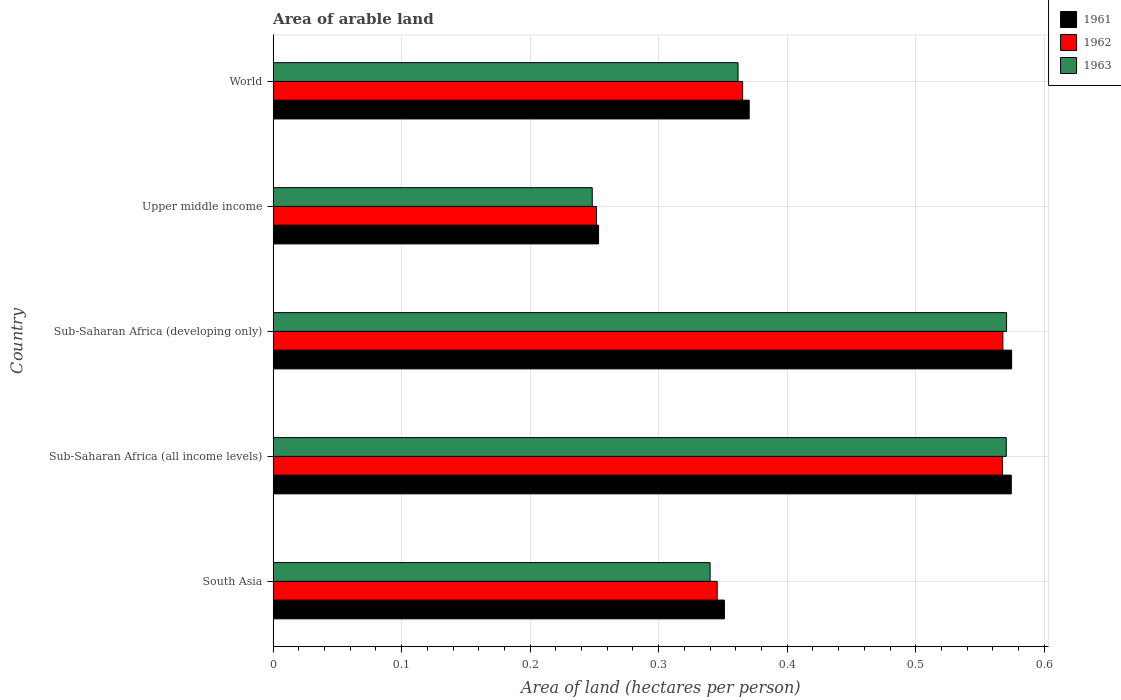How many groups of bars are there?
Provide a short and direct response. 5. Are the number of bars per tick equal to the number of legend labels?
Provide a succinct answer. Yes. How many bars are there on the 5th tick from the top?
Provide a short and direct response. 3. How many bars are there on the 2nd tick from the bottom?
Make the answer very short. 3. What is the total arable land in 1962 in Sub-Saharan Africa (developing only)?
Give a very brief answer. 0.57. Across all countries, what is the maximum total arable land in 1963?
Keep it short and to the point. 0.57. Across all countries, what is the minimum total arable land in 1962?
Your answer should be compact. 0.25. In which country was the total arable land in 1961 maximum?
Keep it short and to the point. Sub-Saharan Africa (developing only). In which country was the total arable land in 1961 minimum?
Offer a very short reply. Upper middle income. What is the total total arable land in 1962 in the graph?
Your answer should be very brief. 2.1. What is the difference between the total arable land in 1963 in Sub-Saharan Africa (all income levels) and that in World?
Keep it short and to the point. 0.21. What is the difference between the total arable land in 1962 in Sub-Saharan Africa (developing only) and the total arable land in 1963 in Sub-Saharan Africa (all income levels)?
Give a very brief answer. -0. What is the average total arable land in 1961 per country?
Keep it short and to the point. 0.42. What is the difference between the total arable land in 1961 and total arable land in 1963 in Sub-Saharan Africa (all income levels)?
Offer a very short reply. 0. In how many countries, is the total arable land in 1963 greater than 0.2 hectares per person?
Offer a very short reply. 5. What is the ratio of the total arable land in 1963 in Sub-Saharan Africa (all income levels) to that in Upper middle income?
Keep it short and to the point. 2.3. Is the total arable land in 1962 in Sub-Saharan Africa (all income levels) less than that in Sub-Saharan Africa (developing only)?
Offer a very short reply. Yes. Is the difference between the total arable land in 1961 in South Asia and Sub-Saharan Africa (all income levels) greater than the difference between the total arable land in 1963 in South Asia and Sub-Saharan Africa (all income levels)?
Your answer should be very brief. Yes. What is the difference between the highest and the second highest total arable land in 1963?
Give a very brief answer. 0. What is the difference between the highest and the lowest total arable land in 1961?
Offer a very short reply. 0.32. Is the sum of the total arable land in 1961 in Upper middle income and World greater than the maximum total arable land in 1963 across all countries?
Your answer should be very brief. Yes. What does the 2nd bar from the bottom in Upper middle income represents?
Offer a very short reply. 1962. How many countries are there in the graph?
Make the answer very short. 5. What is the difference between two consecutive major ticks on the X-axis?
Your answer should be very brief. 0.1. Are the values on the major ticks of X-axis written in scientific E-notation?
Keep it short and to the point. No. How many legend labels are there?
Your answer should be compact. 3. How are the legend labels stacked?
Give a very brief answer. Vertical. What is the title of the graph?
Make the answer very short. Area of arable land. What is the label or title of the X-axis?
Offer a terse response. Area of land (hectares per person). What is the label or title of the Y-axis?
Provide a succinct answer. Country. What is the Area of land (hectares per person) of 1961 in South Asia?
Offer a very short reply. 0.35. What is the Area of land (hectares per person) in 1962 in South Asia?
Your answer should be compact. 0.35. What is the Area of land (hectares per person) in 1963 in South Asia?
Keep it short and to the point. 0.34. What is the Area of land (hectares per person) of 1961 in Sub-Saharan Africa (all income levels)?
Offer a very short reply. 0.57. What is the Area of land (hectares per person) of 1962 in Sub-Saharan Africa (all income levels)?
Your response must be concise. 0.57. What is the Area of land (hectares per person) of 1963 in Sub-Saharan Africa (all income levels)?
Make the answer very short. 0.57. What is the Area of land (hectares per person) in 1961 in Sub-Saharan Africa (developing only)?
Offer a terse response. 0.57. What is the Area of land (hectares per person) in 1962 in Sub-Saharan Africa (developing only)?
Keep it short and to the point. 0.57. What is the Area of land (hectares per person) of 1963 in Sub-Saharan Africa (developing only)?
Give a very brief answer. 0.57. What is the Area of land (hectares per person) in 1961 in Upper middle income?
Provide a short and direct response. 0.25. What is the Area of land (hectares per person) of 1962 in Upper middle income?
Your response must be concise. 0.25. What is the Area of land (hectares per person) in 1963 in Upper middle income?
Offer a terse response. 0.25. What is the Area of land (hectares per person) in 1961 in World?
Provide a succinct answer. 0.37. What is the Area of land (hectares per person) in 1962 in World?
Your answer should be compact. 0.37. What is the Area of land (hectares per person) in 1963 in World?
Give a very brief answer. 0.36. Across all countries, what is the maximum Area of land (hectares per person) in 1961?
Keep it short and to the point. 0.57. Across all countries, what is the maximum Area of land (hectares per person) in 1962?
Keep it short and to the point. 0.57. Across all countries, what is the maximum Area of land (hectares per person) in 1963?
Your answer should be compact. 0.57. Across all countries, what is the minimum Area of land (hectares per person) in 1961?
Provide a succinct answer. 0.25. Across all countries, what is the minimum Area of land (hectares per person) of 1962?
Your answer should be very brief. 0.25. Across all countries, what is the minimum Area of land (hectares per person) of 1963?
Your answer should be compact. 0.25. What is the total Area of land (hectares per person) of 1961 in the graph?
Keep it short and to the point. 2.12. What is the total Area of land (hectares per person) of 1962 in the graph?
Your answer should be compact. 2.1. What is the total Area of land (hectares per person) in 1963 in the graph?
Provide a succinct answer. 2.09. What is the difference between the Area of land (hectares per person) in 1961 in South Asia and that in Sub-Saharan Africa (all income levels)?
Provide a short and direct response. -0.22. What is the difference between the Area of land (hectares per person) in 1962 in South Asia and that in Sub-Saharan Africa (all income levels)?
Ensure brevity in your answer.  -0.22. What is the difference between the Area of land (hectares per person) of 1963 in South Asia and that in Sub-Saharan Africa (all income levels)?
Give a very brief answer. -0.23. What is the difference between the Area of land (hectares per person) of 1961 in South Asia and that in Sub-Saharan Africa (developing only)?
Your answer should be compact. -0.22. What is the difference between the Area of land (hectares per person) of 1962 in South Asia and that in Sub-Saharan Africa (developing only)?
Offer a terse response. -0.22. What is the difference between the Area of land (hectares per person) of 1963 in South Asia and that in Sub-Saharan Africa (developing only)?
Offer a very short reply. -0.23. What is the difference between the Area of land (hectares per person) of 1961 in South Asia and that in Upper middle income?
Provide a short and direct response. 0.1. What is the difference between the Area of land (hectares per person) of 1962 in South Asia and that in Upper middle income?
Your response must be concise. 0.09. What is the difference between the Area of land (hectares per person) of 1963 in South Asia and that in Upper middle income?
Your answer should be compact. 0.09. What is the difference between the Area of land (hectares per person) of 1961 in South Asia and that in World?
Provide a succinct answer. -0.02. What is the difference between the Area of land (hectares per person) in 1962 in South Asia and that in World?
Your answer should be compact. -0.02. What is the difference between the Area of land (hectares per person) of 1963 in South Asia and that in World?
Your answer should be very brief. -0.02. What is the difference between the Area of land (hectares per person) of 1961 in Sub-Saharan Africa (all income levels) and that in Sub-Saharan Africa (developing only)?
Offer a very short reply. -0. What is the difference between the Area of land (hectares per person) of 1962 in Sub-Saharan Africa (all income levels) and that in Sub-Saharan Africa (developing only)?
Offer a terse response. -0. What is the difference between the Area of land (hectares per person) in 1963 in Sub-Saharan Africa (all income levels) and that in Sub-Saharan Africa (developing only)?
Keep it short and to the point. -0. What is the difference between the Area of land (hectares per person) of 1961 in Sub-Saharan Africa (all income levels) and that in Upper middle income?
Provide a succinct answer. 0.32. What is the difference between the Area of land (hectares per person) in 1962 in Sub-Saharan Africa (all income levels) and that in Upper middle income?
Your response must be concise. 0.32. What is the difference between the Area of land (hectares per person) of 1963 in Sub-Saharan Africa (all income levels) and that in Upper middle income?
Provide a short and direct response. 0.32. What is the difference between the Area of land (hectares per person) of 1961 in Sub-Saharan Africa (all income levels) and that in World?
Keep it short and to the point. 0.2. What is the difference between the Area of land (hectares per person) of 1962 in Sub-Saharan Africa (all income levels) and that in World?
Your response must be concise. 0.2. What is the difference between the Area of land (hectares per person) of 1963 in Sub-Saharan Africa (all income levels) and that in World?
Provide a succinct answer. 0.21. What is the difference between the Area of land (hectares per person) of 1961 in Sub-Saharan Africa (developing only) and that in Upper middle income?
Provide a short and direct response. 0.32. What is the difference between the Area of land (hectares per person) in 1962 in Sub-Saharan Africa (developing only) and that in Upper middle income?
Provide a short and direct response. 0.32. What is the difference between the Area of land (hectares per person) of 1963 in Sub-Saharan Africa (developing only) and that in Upper middle income?
Your answer should be compact. 0.32. What is the difference between the Area of land (hectares per person) of 1961 in Sub-Saharan Africa (developing only) and that in World?
Make the answer very short. 0.2. What is the difference between the Area of land (hectares per person) of 1962 in Sub-Saharan Africa (developing only) and that in World?
Give a very brief answer. 0.2. What is the difference between the Area of land (hectares per person) in 1963 in Sub-Saharan Africa (developing only) and that in World?
Your answer should be compact. 0.21. What is the difference between the Area of land (hectares per person) of 1961 in Upper middle income and that in World?
Provide a succinct answer. -0.12. What is the difference between the Area of land (hectares per person) of 1962 in Upper middle income and that in World?
Keep it short and to the point. -0.11. What is the difference between the Area of land (hectares per person) of 1963 in Upper middle income and that in World?
Ensure brevity in your answer.  -0.11. What is the difference between the Area of land (hectares per person) in 1961 in South Asia and the Area of land (hectares per person) in 1962 in Sub-Saharan Africa (all income levels)?
Your response must be concise. -0.22. What is the difference between the Area of land (hectares per person) in 1961 in South Asia and the Area of land (hectares per person) in 1963 in Sub-Saharan Africa (all income levels)?
Offer a terse response. -0.22. What is the difference between the Area of land (hectares per person) in 1962 in South Asia and the Area of land (hectares per person) in 1963 in Sub-Saharan Africa (all income levels)?
Keep it short and to the point. -0.23. What is the difference between the Area of land (hectares per person) of 1961 in South Asia and the Area of land (hectares per person) of 1962 in Sub-Saharan Africa (developing only)?
Provide a succinct answer. -0.22. What is the difference between the Area of land (hectares per person) in 1961 in South Asia and the Area of land (hectares per person) in 1963 in Sub-Saharan Africa (developing only)?
Keep it short and to the point. -0.22. What is the difference between the Area of land (hectares per person) in 1962 in South Asia and the Area of land (hectares per person) in 1963 in Sub-Saharan Africa (developing only)?
Your answer should be very brief. -0.23. What is the difference between the Area of land (hectares per person) in 1961 in South Asia and the Area of land (hectares per person) in 1962 in Upper middle income?
Give a very brief answer. 0.1. What is the difference between the Area of land (hectares per person) of 1961 in South Asia and the Area of land (hectares per person) of 1963 in Upper middle income?
Provide a short and direct response. 0.1. What is the difference between the Area of land (hectares per person) of 1962 in South Asia and the Area of land (hectares per person) of 1963 in Upper middle income?
Ensure brevity in your answer.  0.1. What is the difference between the Area of land (hectares per person) of 1961 in South Asia and the Area of land (hectares per person) of 1962 in World?
Provide a succinct answer. -0.01. What is the difference between the Area of land (hectares per person) of 1961 in South Asia and the Area of land (hectares per person) of 1963 in World?
Provide a short and direct response. -0.01. What is the difference between the Area of land (hectares per person) in 1962 in South Asia and the Area of land (hectares per person) in 1963 in World?
Your answer should be compact. -0.02. What is the difference between the Area of land (hectares per person) in 1961 in Sub-Saharan Africa (all income levels) and the Area of land (hectares per person) in 1962 in Sub-Saharan Africa (developing only)?
Provide a succinct answer. 0.01. What is the difference between the Area of land (hectares per person) of 1961 in Sub-Saharan Africa (all income levels) and the Area of land (hectares per person) of 1963 in Sub-Saharan Africa (developing only)?
Keep it short and to the point. 0. What is the difference between the Area of land (hectares per person) in 1962 in Sub-Saharan Africa (all income levels) and the Area of land (hectares per person) in 1963 in Sub-Saharan Africa (developing only)?
Make the answer very short. -0. What is the difference between the Area of land (hectares per person) in 1961 in Sub-Saharan Africa (all income levels) and the Area of land (hectares per person) in 1962 in Upper middle income?
Your response must be concise. 0.32. What is the difference between the Area of land (hectares per person) of 1961 in Sub-Saharan Africa (all income levels) and the Area of land (hectares per person) of 1963 in Upper middle income?
Offer a terse response. 0.33. What is the difference between the Area of land (hectares per person) of 1962 in Sub-Saharan Africa (all income levels) and the Area of land (hectares per person) of 1963 in Upper middle income?
Provide a short and direct response. 0.32. What is the difference between the Area of land (hectares per person) of 1961 in Sub-Saharan Africa (all income levels) and the Area of land (hectares per person) of 1962 in World?
Offer a terse response. 0.21. What is the difference between the Area of land (hectares per person) in 1961 in Sub-Saharan Africa (all income levels) and the Area of land (hectares per person) in 1963 in World?
Offer a terse response. 0.21. What is the difference between the Area of land (hectares per person) in 1962 in Sub-Saharan Africa (all income levels) and the Area of land (hectares per person) in 1963 in World?
Your response must be concise. 0.21. What is the difference between the Area of land (hectares per person) of 1961 in Sub-Saharan Africa (developing only) and the Area of land (hectares per person) of 1962 in Upper middle income?
Your answer should be very brief. 0.32. What is the difference between the Area of land (hectares per person) in 1961 in Sub-Saharan Africa (developing only) and the Area of land (hectares per person) in 1963 in Upper middle income?
Your answer should be very brief. 0.33. What is the difference between the Area of land (hectares per person) in 1962 in Sub-Saharan Africa (developing only) and the Area of land (hectares per person) in 1963 in Upper middle income?
Provide a short and direct response. 0.32. What is the difference between the Area of land (hectares per person) in 1961 in Sub-Saharan Africa (developing only) and the Area of land (hectares per person) in 1962 in World?
Your answer should be very brief. 0.21. What is the difference between the Area of land (hectares per person) in 1961 in Sub-Saharan Africa (developing only) and the Area of land (hectares per person) in 1963 in World?
Provide a succinct answer. 0.21. What is the difference between the Area of land (hectares per person) in 1962 in Sub-Saharan Africa (developing only) and the Area of land (hectares per person) in 1963 in World?
Keep it short and to the point. 0.21. What is the difference between the Area of land (hectares per person) in 1961 in Upper middle income and the Area of land (hectares per person) in 1962 in World?
Offer a terse response. -0.11. What is the difference between the Area of land (hectares per person) of 1961 in Upper middle income and the Area of land (hectares per person) of 1963 in World?
Provide a short and direct response. -0.11. What is the difference between the Area of land (hectares per person) of 1962 in Upper middle income and the Area of land (hectares per person) of 1963 in World?
Provide a succinct answer. -0.11. What is the average Area of land (hectares per person) in 1961 per country?
Offer a very short reply. 0.42. What is the average Area of land (hectares per person) in 1962 per country?
Offer a very short reply. 0.42. What is the average Area of land (hectares per person) of 1963 per country?
Your answer should be compact. 0.42. What is the difference between the Area of land (hectares per person) of 1961 and Area of land (hectares per person) of 1962 in South Asia?
Offer a terse response. 0.01. What is the difference between the Area of land (hectares per person) in 1961 and Area of land (hectares per person) in 1963 in South Asia?
Your response must be concise. 0.01. What is the difference between the Area of land (hectares per person) of 1962 and Area of land (hectares per person) of 1963 in South Asia?
Your answer should be very brief. 0.01. What is the difference between the Area of land (hectares per person) of 1961 and Area of land (hectares per person) of 1962 in Sub-Saharan Africa (all income levels)?
Provide a short and direct response. 0.01. What is the difference between the Area of land (hectares per person) in 1961 and Area of land (hectares per person) in 1963 in Sub-Saharan Africa (all income levels)?
Ensure brevity in your answer.  0. What is the difference between the Area of land (hectares per person) in 1962 and Area of land (hectares per person) in 1963 in Sub-Saharan Africa (all income levels)?
Ensure brevity in your answer.  -0. What is the difference between the Area of land (hectares per person) of 1961 and Area of land (hectares per person) of 1962 in Sub-Saharan Africa (developing only)?
Provide a short and direct response. 0.01. What is the difference between the Area of land (hectares per person) of 1961 and Area of land (hectares per person) of 1963 in Sub-Saharan Africa (developing only)?
Offer a very short reply. 0. What is the difference between the Area of land (hectares per person) in 1962 and Area of land (hectares per person) in 1963 in Sub-Saharan Africa (developing only)?
Your response must be concise. -0. What is the difference between the Area of land (hectares per person) of 1961 and Area of land (hectares per person) of 1962 in Upper middle income?
Ensure brevity in your answer.  0. What is the difference between the Area of land (hectares per person) in 1961 and Area of land (hectares per person) in 1963 in Upper middle income?
Offer a terse response. 0. What is the difference between the Area of land (hectares per person) of 1962 and Area of land (hectares per person) of 1963 in Upper middle income?
Provide a succinct answer. 0. What is the difference between the Area of land (hectares per person) in 1961 and Area of land (hectares per person) in 1962 in World?
Your response must be concise. 0.01. What is the difference between the Area of land (hectares per person) in 1961 and Area of land (hectares per person) in 1963 in World?
Provide a succinct answer. 0.01. What is the difference between the Area of land (hectares per person) of 1962 and Area of land (hectares per person) of 1963 in World?
Your answer should be compact. 0. What is the ratio of the Area of land (hectares per person) in 1961 in South Asia to that in Sub-Saharan Africa (all income levels)?
Offer a terse response. 0.61. What is the ratio of the Area of land (hectares per person) in 1962 in South Asia to that in Sub-Saharan Africa (all income levels)?
Make the answer very short. 0.61. What is the ratio of the Area of land (hectares per person) of 1963 in South Asia to that in Sub-Saharan Africa (all income levels)?
Your answer should be very brief. 0.6. What is the ratio of the Area of land (hectares per person) of 1961 in South Asia to that in Sub-Saharan Africa (developing only)?
Keep it short and to the point. 0.61. What is the ratio of the Area of land (hectares per person) of 1962 in South Asia to that in Sub-Saharan Africa (developing only)?
Give a very brief answer. 0.61. What is the ratio of the Area of land (hectares per person) in 1963 in South Asia to that in Sub-Saharan Africa (developing only)?
Offer a very short reply. 0.6. What is the ratio of the Area of land (hectares per person) of 1961 in South Asia to that in Upper middle income?
Ensure brevity in your answer.  1.39. What is the ratio of the Area of land (hectares per person) in 1962 in South Asia to that in Upper middle income?
Your response must be concise. 1.37. What is the ratio of the Area of land (hectares per person) in 1963 in South Asia to that in Upper middle income?
Your response must be concise. 1.37. What is the ratio of the Area of land (hectares per person) of 1961 in South Asia to that in World?
Ensure brevity in your answer.  0.95. What is the ratio of the Area of land (hectares per person) of 1962 in South Asia to that in World?
Your answer should be very brief. 0.95. What is the ratio of the Area of land (hectares per person) in 1963 in South Asia to that in World?
Provide a short and direct response. 0.94. What is the ratio of the Area of land (hectares per person) of 1962 in Sub-Saharan Africa (all income levels) to that in Sub-Saharan Africa (developing only)?
Give a very brief answer. 1. What is the ratio of the Area of land (hectares per person) of 1961 in Sub-Saharan Africa (all income levels) to that in Upper middle income?
Your answer should be compact. 2.27. What is the ratio of the Area of land (hectares per person) in 1962 in Sub-Saharan Africa (all income levels) to that in Upper middle income?
Your answer should be compact. 2.26. What is the ratio of the Area of land (hectares per person) in 1963 in Sub-Saharan Africa (all income levels) to that in Upper middle income?
Offer a very short reply. 2.3. What is the ratio of the Area of land (hectares per person) of 1961 in Sub-Saharan Africa (all income levels) to that in World?
Provide a short and direct response. 1.55. What is the ratio of the Area of land (hectares per person) of 1962 in Sub-Saharan Africa (all income levels) to that in World?
Offer a terse response. 1.55. What is the ratio of the Area of land (hectares per person) in 1963 in Sub-Saharan Africa (all income levels) to that in World?
Your answer should be very brief. 1.58. What is the ratio of the Area of land (hectares per person) of 1961 in Sub-Saharan Africa (developing only) to that in Upper middle income?
Offer a very short reply. 2.27. What is the ratio of the Area of land (hectares per person) of 1962 in Sub-Saharan Africa (developing only) to that in Upper middle income?
Offer a terse response. 2.26. What is the ratio of the Area of land (hectares per person) of 1963 in Sub-Saharan Africa (developing only) to that in Upper middle income?
Your answer should be compact. 2.3. What is the ratio of the Area of land (hectares per person) of 1961 in Sub-Saharan Africa (developing only) to that in World?
Give a very brief answer. 1.55. What is the ratio of the Area of land (hectares per person) of 1962 in Sub-Saharan Africa (developing only) to that in World?
Your answer should be very brief. 1.55. What is the ratio of the Area of land (hectares per person) in 1963 in Sub-Saharan Africa (developing only) to that in World?
Your response must be concise. 1.58. What is the ratio of the Area of land (hectares per person) of 1961 in Upper middle income to that in World?
Make the answer very short. 0.68. What is the ratio of the Area of land (hectares per person) in 1962 in Upper middle income to that in World?
Keep it short and to the point. 0.69. What is the ratio of the Area of land (hectares per person) in 1963 in Upper middle income to that in World?
Give a very brief answer. 0.69. What is the difference between the highest and the second highest Area of land (hectares per person) in 1961?
Provide a succinct answer. 0. What is the difference between the highest and the lowest Area of land (hectares per person) in 1961?
Keep it short and to the point. 0.32. What is the difference between the highest and the lowest Area of land (hectares per person) of 1962?
Keep it short and to the point. 0.32. What is the difference between the highest and the lowest Area of land (hectares per person) of 1963?
Your answer should be very brief. 0.32. 